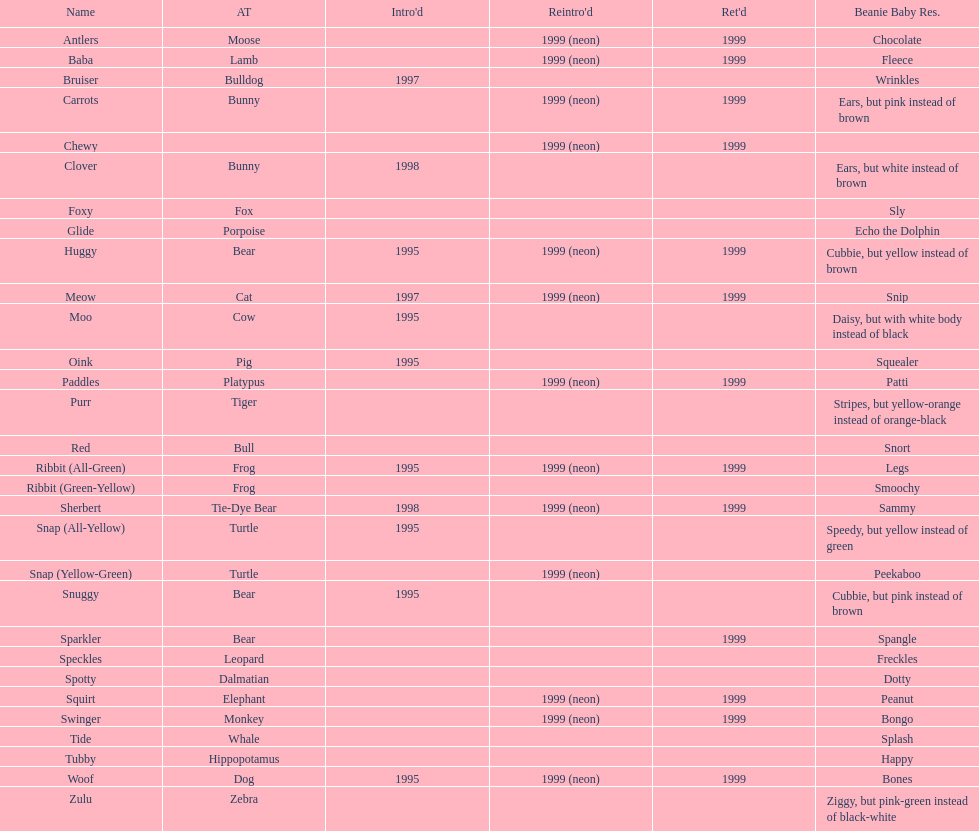How many monkey cushion friends were there? 1. 